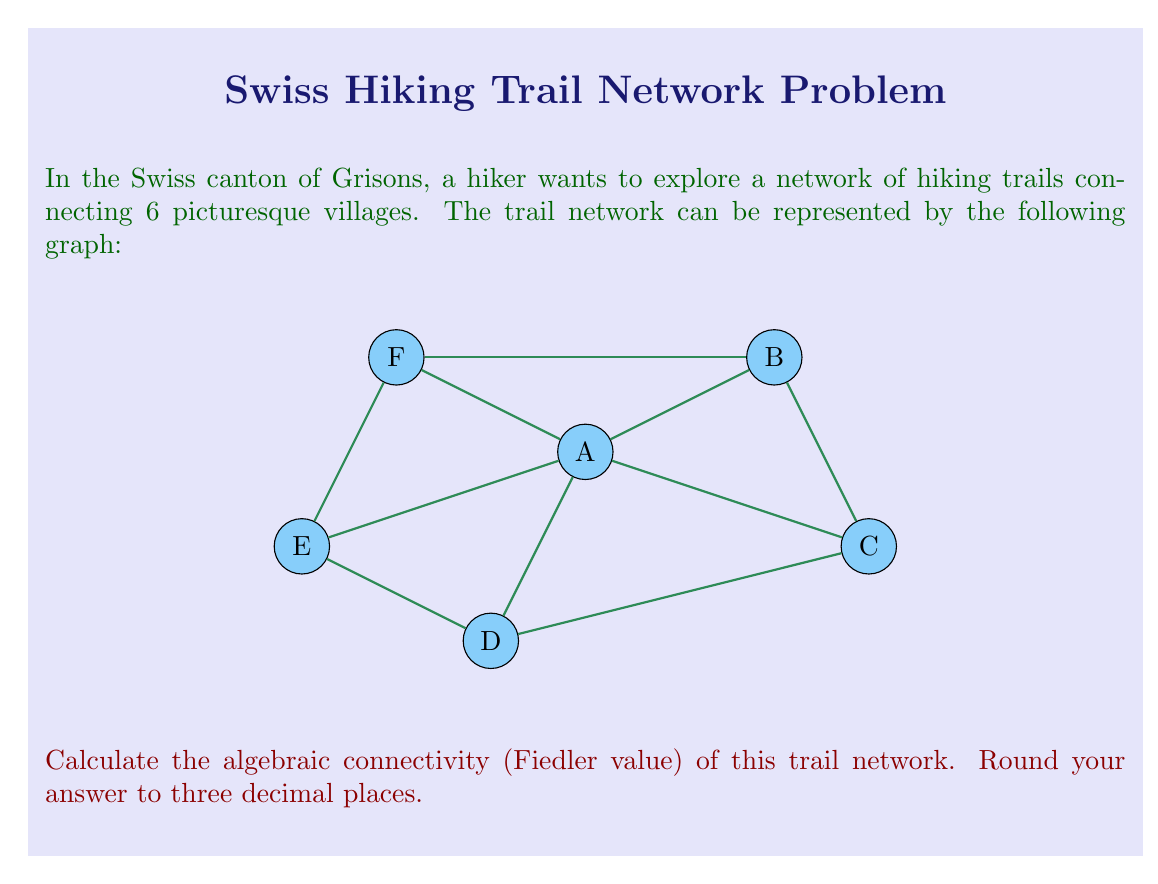Can you solve this math problem? To find the algebraic connectivity of the graph, we need to follow these steps:

1) First, construct the Laplacian matrix $L$ of the graph. For a graph with $n$ vertices, $L = D - A$, where $D$ is the degree matrix and $A$ is the adjacency matrix.

2) The degree matrix $D$ is:
   $$D = \begin{pmatrix}
   5 & 0 & 0 & 0 & 0 & 0 \\
   0 & 3 & 0 & 0 & 0 & 0 \\
   0 & 0 & 3 & 0 & 0 & 0 \\
   0 & 0 & 0 & 3 & 0 & 0 \\
   0 & 0 & 0 & 0 & 3 & 0 \\
   0 & 0 & 0 & 0 & 0 & 3
   \end{pmatrix}$$

3) The adjacency matrix $A$ is:
   $$A = \begin{pmatrix}
   0 & 1 & 1 & 1 & 1 & 1 \\
   1 & 0 & 1 & 0 & 0 & 1 \\
   1 & 1 & 0 & 1 & 0 & 0 \\
   1 & 0 & 1 & 0 & 1 & 0 \\
   1 & 0 & 0 & 1 & 0 & 1 \\
   1 & 1 & 0 & 0 & 1 & 0
   \end{pmatrix}$$

4) The Laplacian matrix $L = D - A$ is:
   $$L = \begin{pmatrix}
   5 & -1 & -1 & -1 & -1 & -1 \\
   -1 & 3 & -1 & 0 & 0 & -1 \\
   -1 & -1 & 3 & -1 & 0 & 0 \\
   -1 & 0 & -1 & 3 & -1 & 0 \\
   -1 & 0 & 0 & -1 & 3 & -1 \\
   -1 & -1 & 0 & 0 & -1 & 3
   \end{pmatrix}$$

5) The algebraic connectivity is the second smallest eigenvalue of $L$. We can calculate the eigenvalues using a computer algebra system or numerical methods.

6) The eigenvalues of $L$ are approximately:
   $0, 1.2679, 3, 3, 5, 5.7321$

7) The second smallest eigenvalue, known as the Fiedler value, is approximately 1.2679.

Rounding to three decimal places, we get 1.268.
Answer: 1.268 